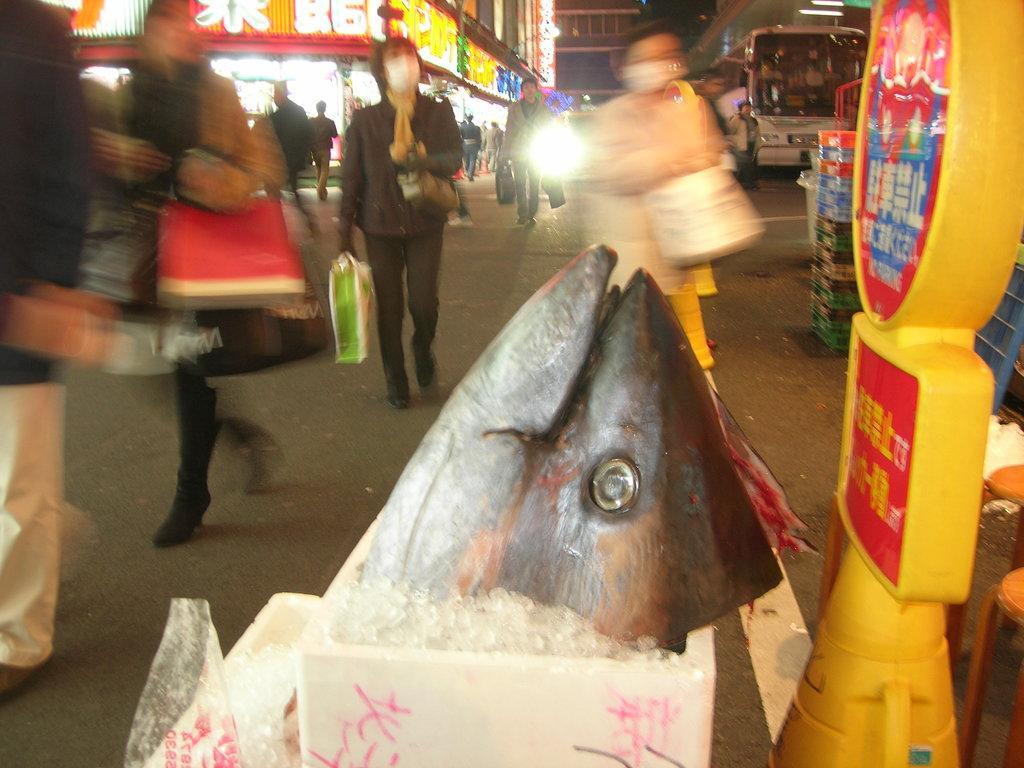Describe this image in one or two sentences. In the center of the image there is a fish. On the right side of the image there is sign board. In the background there are persons, bus, road and buildings. 